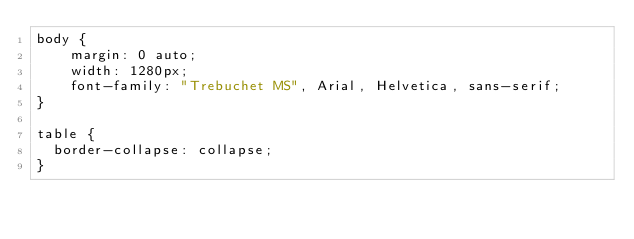<code> <loc_0><loc_0><loc_500><loc_500><_CSS_>body {
    margin: 0 auto;
    width: 1280px;
    font-family: "Trebuchet MS", Arial, Helvetica, sans-serif;
}

table {
  border-collapse: collapse;
}
</code> 